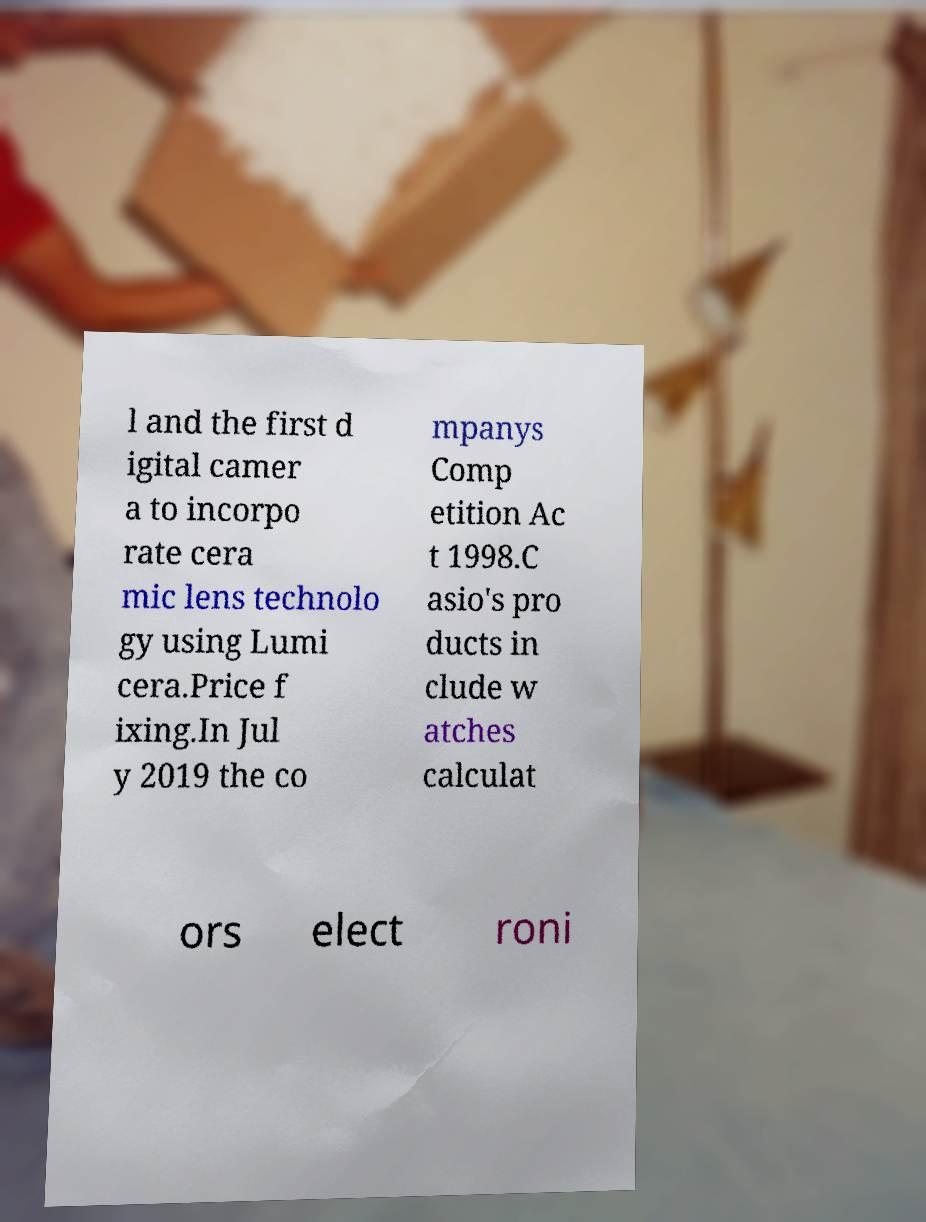Please identify and transcribe the text found in this image. l and the first d igital camer a to incorpo rate cera mic lens technolo gy using Lumi cera.Price f ixing.In Jul y 2019 the co mpanys Comp etition Ac t 1998.C asio's pro ducts in clude w atches calculat ors elect roni 